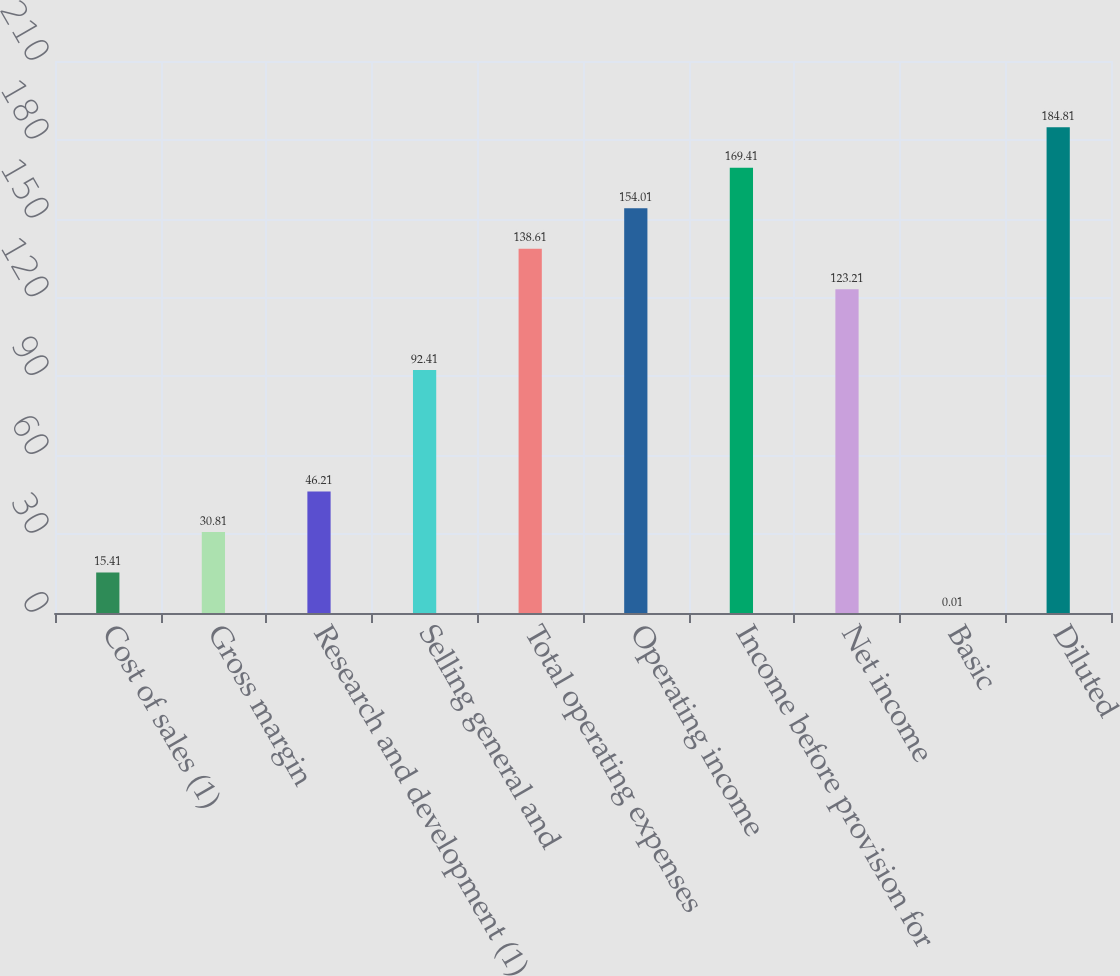Convert chart to OTSL. <chart><loc_0><loc_0><loc_500><loc_500><bar_chart><fcel>Cost of sales (1)<fcel>Gross margin<fcel>Research and development (1)<fcel>Selling general and<fcel>Total operating expenses<fcel>Operating income<fcel>Income before provision for<fcel>Net income<fcel>Basic<fcel>Diluted<nl><fcel>15.41<fcel>30.81<fcel>46.21<fcel>92.41<fcel>138.61<fcel>154.01<fcel>169.41<fcel>123.21<fcel>0.01<fcel>184.81<nl></chart> 